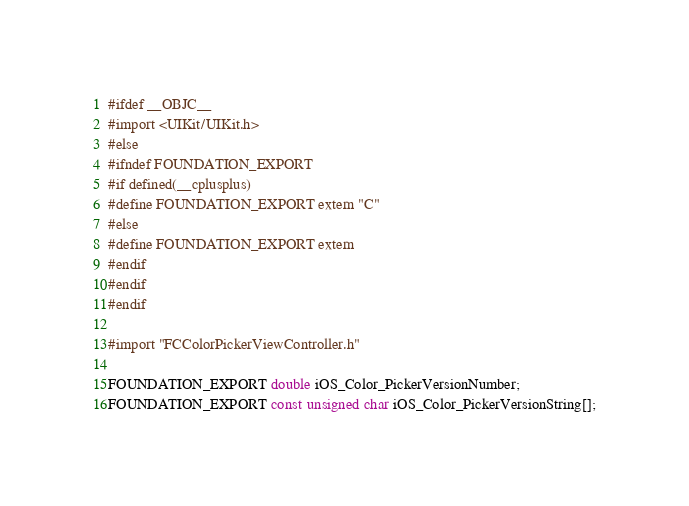<code> <loc_0><loc_0><loc_500><loc_500><_C_>#ifdef __OBJC__
#import <UIKit/UIKit.h>
#else
#ifndef FOUNDATION_EXPORT
#if defined(__cplusplus)
#define FOUNDATION_EXPORT extern "C"
#else
#define FOUNDATION_EXPORT extern
#endif
#endif
#endif

#import "FCColorPickerViewController.h"

FOUNDATION_EXPORT double iOS_Color_PickerVersionNumber;
FOUNDATION_EXPORT const unsigned char iOS_Color_PickerVersionString[];

</code> 